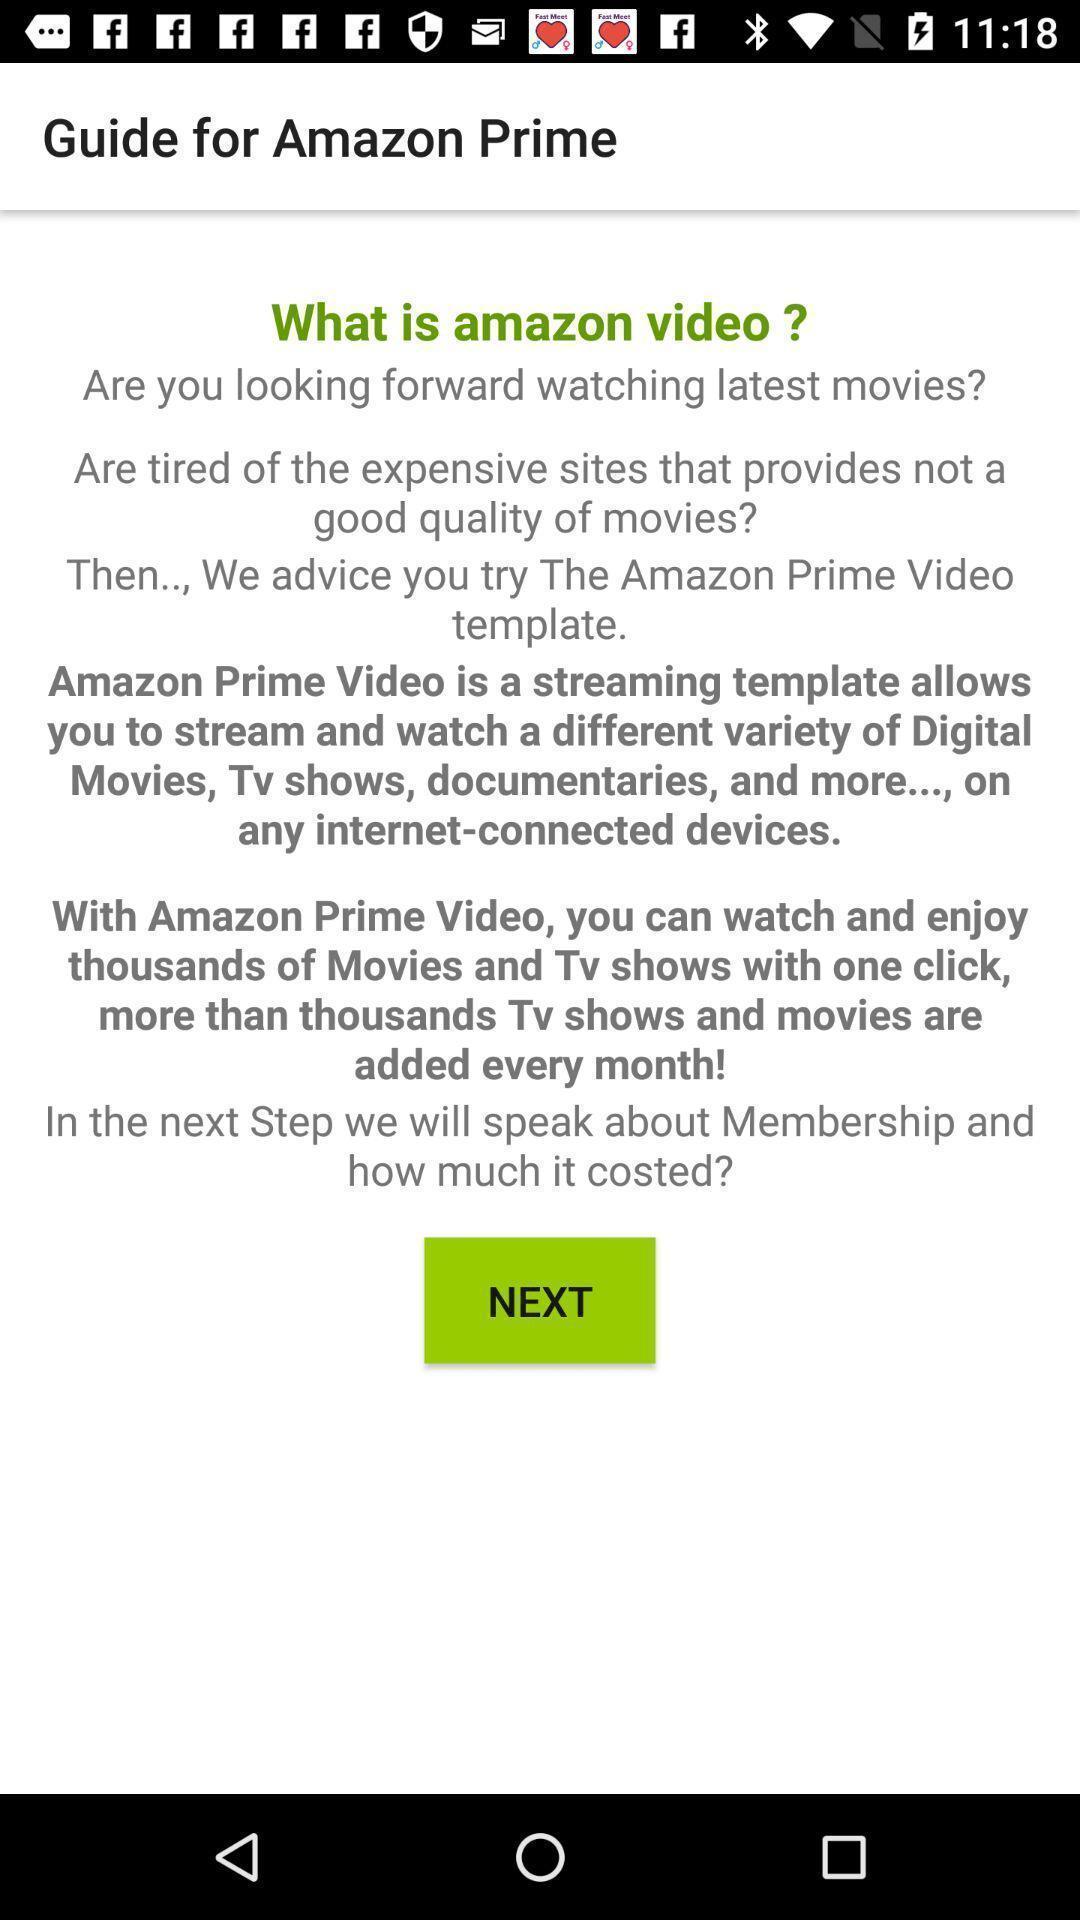What is the overall content of this screenshot? Screen displaying to guide for an application. 